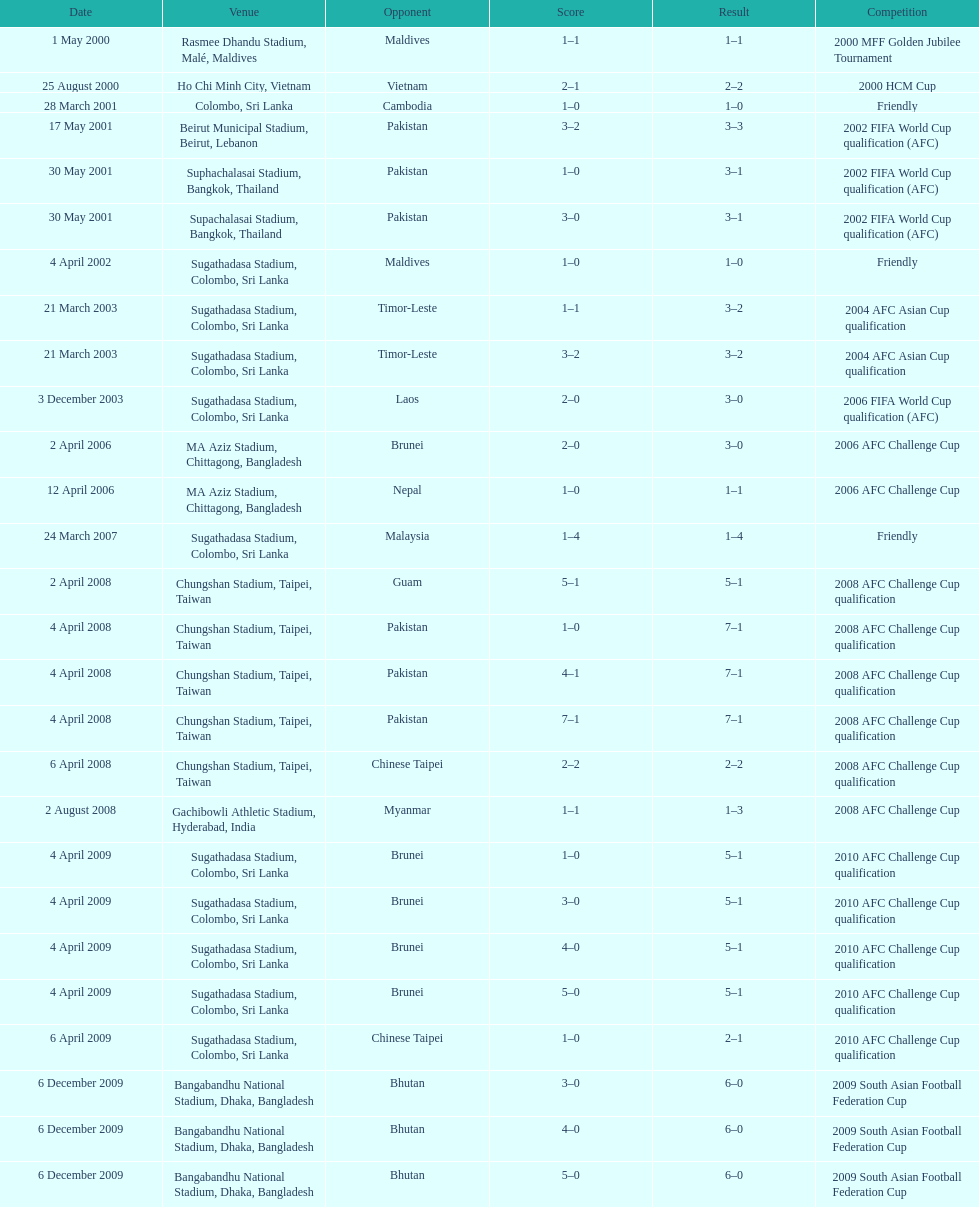What is the top listed venue in the table? Rasmee Dhandu Stadium, Malé, Maldives. 